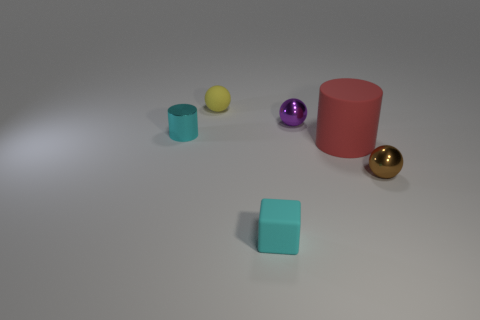Are there more small brown metal objects than small red shiny cylinders?
Make the answer very short. Yes. What size is the thing that is both on the left side of the tiny cyan rubber object and in front of the small purple ball?
Your answer should be compact. Small. There is a tiny object that is the same color as the rubber block; what is its material?
Ensure brevity in your answer.  Metal. Are there an equal number of small cyan shiny objects that are on the right side of the small purple object and small brown balls?
Provide a succinct answer. No. Do the brown metal object and the cyan cylinder have the same size?
Offer a terse response. Yes. What is the color of the thing that is both in front of the large red rubber thing and on the right side of the small purple thing?
Offer a terse response. Brown. The small cyan object to the left of the cyan cube that is in front of the big object is made of what material?
Provide a succinct answer. Metal. The yellow rubber object that is the same shape as the tiny brown shiny object is what size?
Provide a short and direct response. Small. There is a tiny ball on the right side of the tiny purple sphere; is it the same color as the metallic cylinder?
Ensure brevity in your answer.  No. Is the number of purple metal balls less than the number of small yellow metal balls?
Keep it short and to the point. No. 